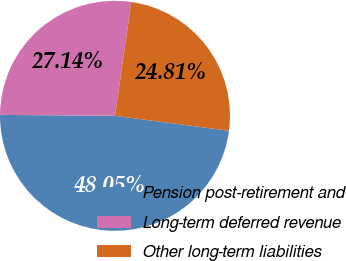Convert chart. <chart><loc_0><loc_0><loc_500><loc_500><pie_chart><fcel>Pension post-retirement and<fcel>Long-term deferred revenue<fcel>Other long-term liabilities<nl><fcel>48.05%<fcel>27.14%<fcel>24.81%<nl></chart> 